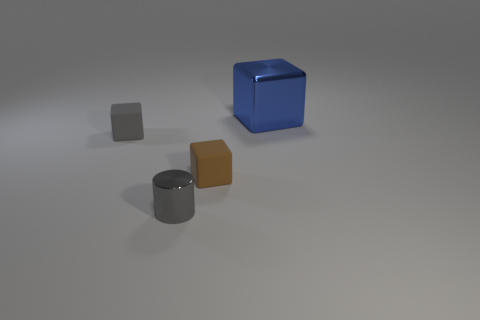Add 2 small blue blocks. How many objects exist? 6 Add 2 tiny brown things. How many tiny brown things are left? 3 Add 1 tiny matte objects. How many tiny matte objects exist? 3 Subtract all brown cubes. How many cubes are left? 2 Subtract all blue shiny blocks. How many blocks are left? 2 Subtract 0 green cylinders. How many objects are left? 4 Subtract all cubes. How many objects are left? 1 Subtract 1 cubes. How many cubes are left? 2 Subtract all red blocks. Subtract all purple balls. How many blocks are left? 3 Subtract all gray cylinders. How many cyan cubes are left? 0 